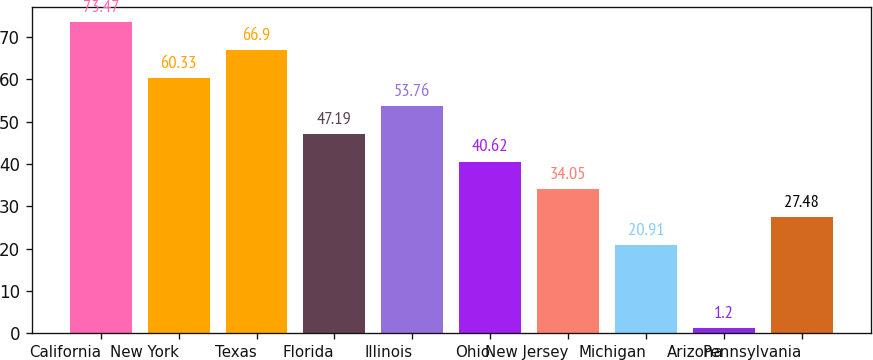Convert chart. <chart><loc_0><loc_0><loc_500><loc_500><bar_chart><fcel>California<fcel>New York<fcel>Texas<fcel>Florida<fcel>Illinois<fcel>Ohio<fcel>New Jersey<fcel>Michigan<fcel>Arizona<fcel>Pennsylvania<nl><fcel>73.47<fcel>60.33<fcel>66.9<fcel>47.19<fcel>53.76<fcel>40.62<fcel>34.05<fcel>20.91<fcel>1.2<fcel>27.48<nl></chart> 